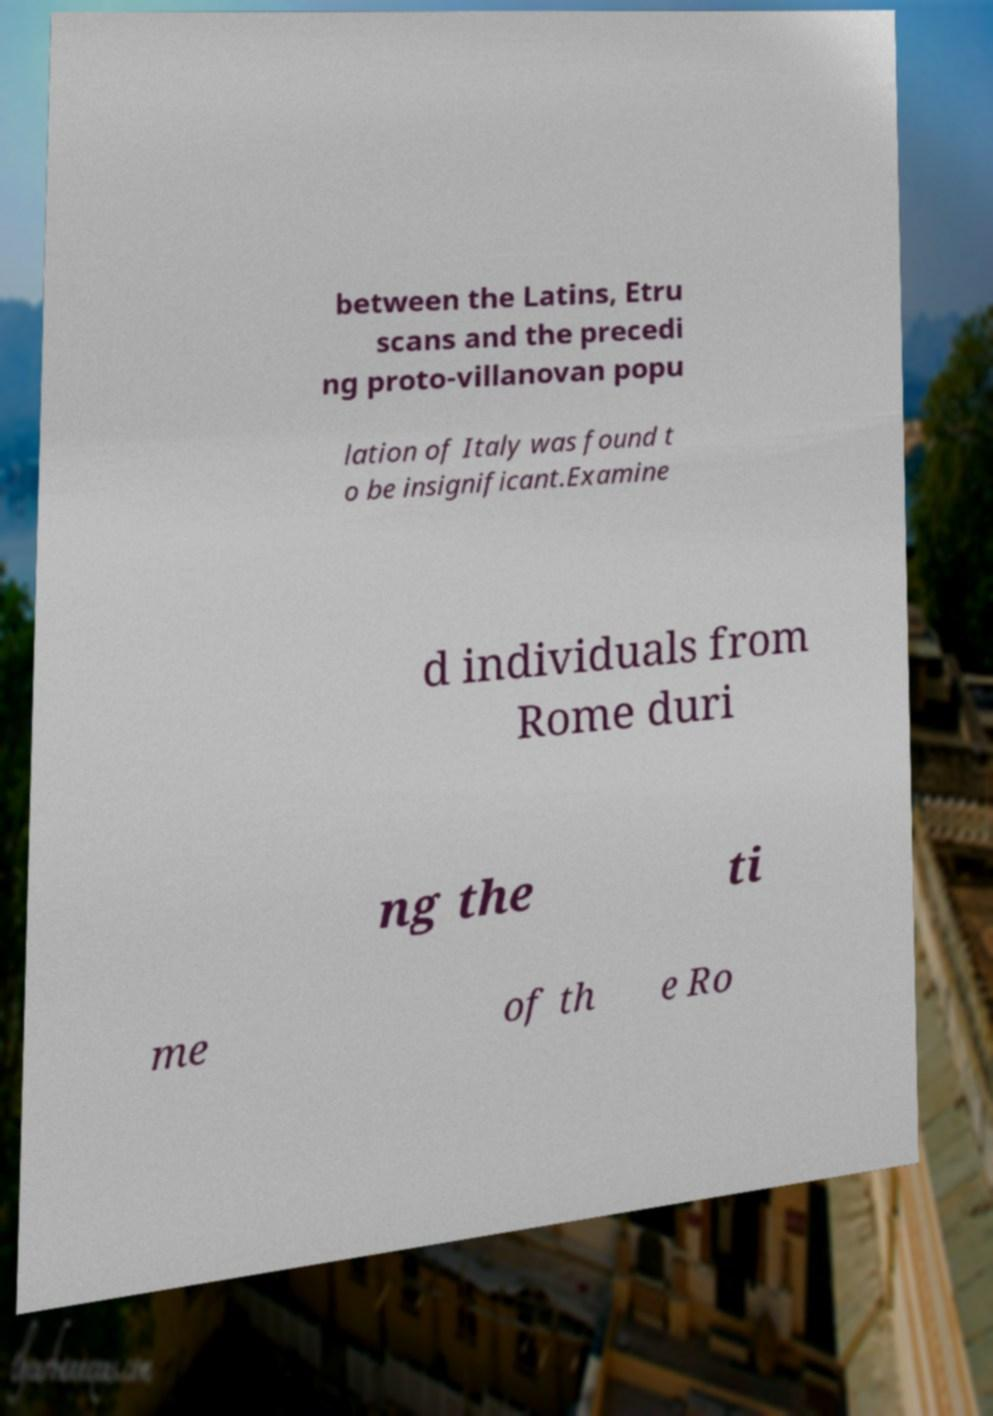There's text embedded in this image that I need extracted. Can you transcribe it verbatim? between the Latins, Etru scans and the precedi ng proto-villanovan popu lation of Italy was found t o be insignificant.Examine d individuals from Rome duri ng the ti me of th e Ro 